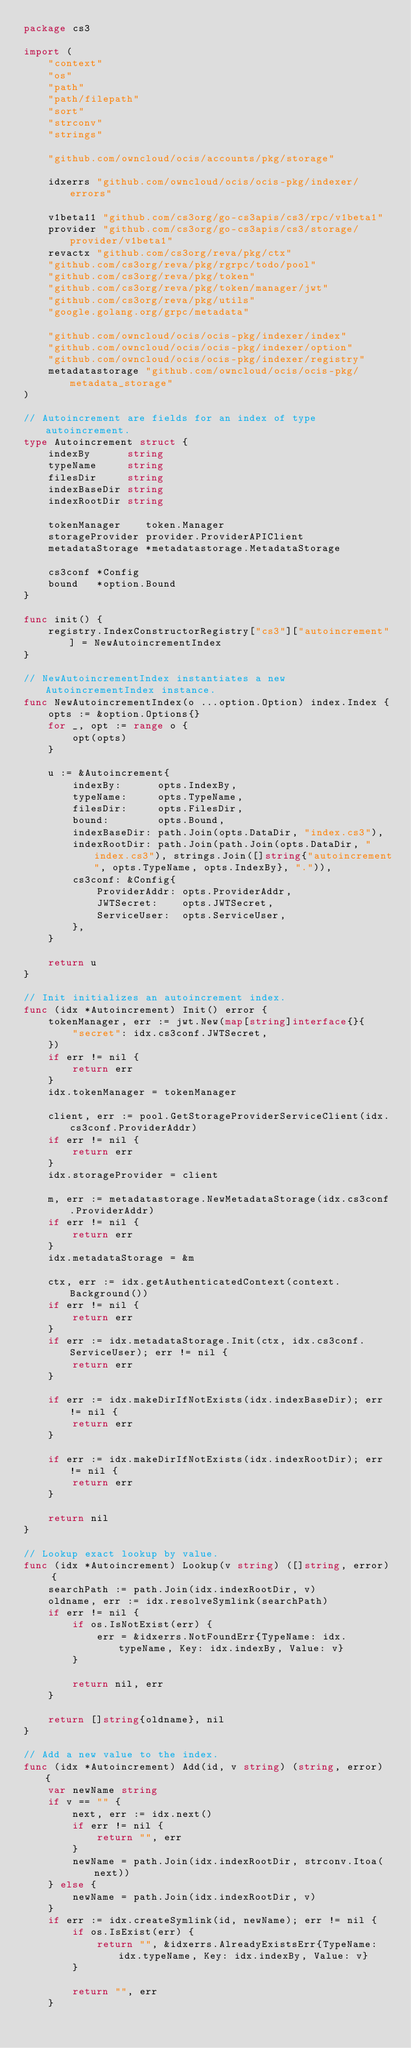<code> <loc_0><loc_0><loc_500><loc_500><_Go_>package cs3

import (
	"context"
	"os"
	"path"
	"path/filepath"
	"sort"
	"strconv"
	"strings"

	"github.com/owncloud/ocis/accounts/pkg/storage"

	idxerrs "github.com/owncloud/ocis/ocis-pkg/indexer/errors"

	v1beta11 "github.com/cs3org/go-cs3apis/cs3/rpc/v1beta1"
	provider "github.com/cs3org/go-cs3apis/cs3/storage/provider/v1beta1"
	revactx "github.com/cs3org/reva/pkg/ctx"
	"github.com/cs3org/reva/pkg/rgrpc/todo/pool"
	"github.com/cs3org/reva/pkg/token"
	"github.com/cs3org/reva/pkg/token/manager/jwt"
	"github.com/cs3org/reva/pkg/utils"
	"google.golang.org/grpc/metadata"

	"github.com/owncloud/ocis/ocis-pkg/indexer/index"
	"github.com/owncloud/ocis/ocis-pkg/indexer/option"
	"github.com/owncloud/ocis/ocis-pkg/indexer/registry"
	metadatastorage "github.com/owncloud/ocis/ocis-pkg/metadata_storage"
)

// Autoincrement are fields for an index of type autoincrement.
type Autoincrement struct {
	indexBy      string
	typeName     string
	filesDir     string
	indexBaseDir string
	indexRootDir string

	tokenManager    token.Manager
	storageProvider provider.ProviderAPIClient
	metadataStorage *metadatastorage.MetadataStorage

	cs3conf *Config
	bound   *option.Bound
}

func init() {
	registry.IndexConstructorRegistry["cs3"]["autoincrement"] = NewAutoincrementIndex
}

// NewAutoincrementIndex instantiates a new AutoincrementIndex instance.
func NewAutoincrementIndex(o ...option.Option) index.Index {
	opts := &option.Options{}
	for _, opt := range o {
		opt(opts)
	}

	u := &Autoincrement{
		indexBy:      opts.IndexBy,
		typeName:     opts.TypeName,
		filesDir:     opts.FilesDir,
		bound:        opts.Bound,
		indexBaseDir: path.Join(opts.DataDir, "index.cs3"),
		indexRootDir: path.Join(path.Join(opts.DataDir, "index.cs3"), strings.Join([]string{"autoincrement", opts.TypeName, opts.IndexBy}, ".")),
		cs3conf: &Config{
			ProviderAddr: opts.ProviderAddr,
			JWTSecret:    opts.JWTSecret,
			ServiceUser:  opts.ServiceUser,
		},
	}

	return u
}

// Init initializes an autoincrement index.
func (idx *Autoincrement) Init() error {
	tokenManager, err := jwt.New(map[string]interface{}{
		"secret": idx.cs3conf.JWTSecret,
	})
	if err != nil {
		return err
	}
	idx.tokenManager = tokenManager

	client, err := pool.GetStorageProviderServiceClient(idx.cs3conf.ProviderAddr)
	if err != nil {
		return err
	}
	idx.storageProvider = client

	m, err := metadatastorage.NewMetadataStorage(idx.cs3conf.ProviderAddr)
	if err != nil {
		return err
	}
	idx.metadataStorage = &m

	ctx, err := idx.getAuthenticatedContext(context.Background())
	if err != nil {
		return err
	}
	if err := idx.metadataStorage.Init(ctx, idx.cs3conf.ServiceUser); err != nil {
		return err
	}

	if err := idx.makeDirIfNotExists(idx.indexBaseDir); err != nil {
		return err
	}

	if err := idx.makeDirIfNotExists(idx.indexRootDir); err != nil {
		return err
	}

	return nil
}

// Lookup exact lookup by value.
func (idx *Autoincrement) Lookup(v string) ([]string, error) {
	searchPath := path.Join(idx.indexRootDir, v)
	oldname, err := idx.resolveSymlink(searchPath)
	if err != nil {
		if os.IsNotExist(err) {
			err = &idxerrs.NotFoundErr{TypeName: idx.typeName, Key: idx.indexBy, Value: v}
		}

		return nil, err
	}

	return []string{oldname}, nil
}

// Add a new value to the index.
func (idx *Autoincrement) Add(id, v string) (string, error) {
	var newName string
	if v == "" {
		next, err := idx.next()
		if err != nil {
			return "", err
		}
		newName = path.Join(idx.indexRootDir, strconv.Itoa(next))
	} else {
		newName = path.Join(idx.indexRootDir, v)
	}
	if err := idx.createSymlink(id, newName); err != nil {
		if os.IsExist(err) {
			return "", &idxerrs.AlreadyExistsErr{TypeName: idx.typeName, Key: idx.indexBy, Value: v}
		}

		return "", err
	}
</code> 